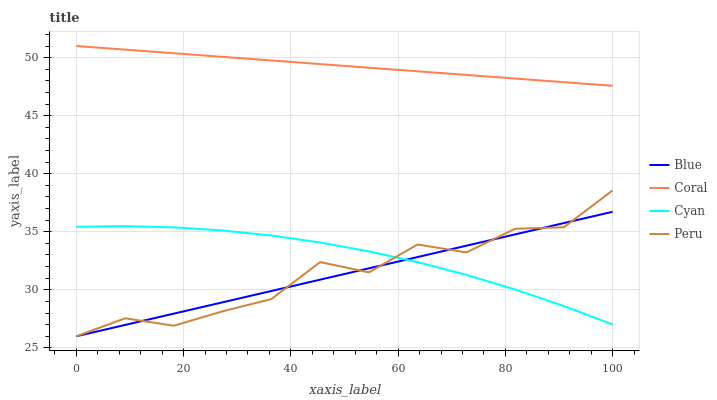Does Blue have the minimum area under the curve?
Answer yes or no. Yes. Does Coral have the maximum area under the curve?
Answer yes or no. Yes. Does Cyan have the minimum area under the curve?
Answer yes or no. No. Does Cyan have the maximum area under the curve?
Answer yes or no. No. Is Coral the smoothest?
Answer yes or no. Yes. Is Peru the roughest?
Answer yes or no. Yes. Is Cyan the smoothest?
Answer yes or no. No. Is Cyan the roughest?
Answer yes or no. No. Does Blue have the lowest value?
Answer yes or no. Yes. Does Cyan have the lowest value?
Answer yes or no. No. Does Coral have the highest value?
Answer yes or no. Yes. Does Cyan have the highest value?
Answer yes or no. No. Is Blue less than Coral?
Answer yes or no. Yes. Is Coral greater than Blue?
Answer yes or no. Yes. Does Blue intersect Peru?
Answer yes or no. Yes. Is Blue less than Peru?
Answer yes or no. No. Is Blue greater than Peru?
Answer yes or no. No. Does Blue intersect Coral?
Answer yes or no. No. 